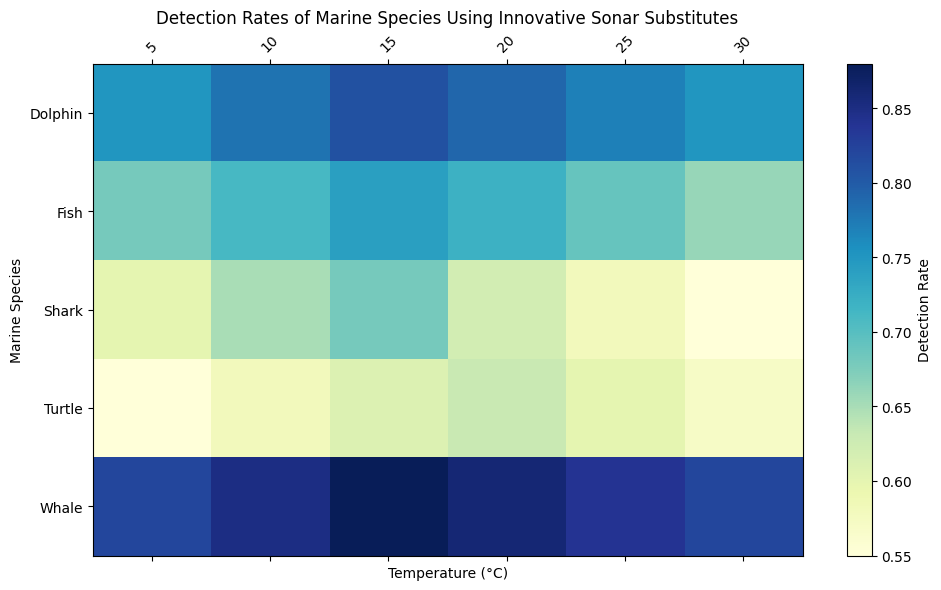What is the detection rate of dolphins at 15°C? Locate the row for Dolphins and the column for 15°C. The value at their intersection is 0.81.
Answer: 0.81 Which marine species has the highest detection rate at 10°C? Compare the detection rates at 10°C across all species. Whale has the highest value at 0.85.
Answer: Whale How does the detection rate of turtles change from 5°C to 25°C? Locate the detection rates for Turtles at 5°C (0.55) and 25°C (0.60). The rate increases as the temperature rises from 5°C to 25°C.
Answer: Increases What is the average detection rate for sharks across all temperatures? Sum the detection rates for Sharks at all temperatures (0.60 + 0.65 + 0.68 + 0.62 + 0.58 + 0.55) = 3.68. Divide by the number of temperatures (6). 3.68 / 6 = 0.613.
Answer: 0.613 Which species shows the least variation in detection rates across temperatures? Calculate the range of detection rates for each species. Dolphins range from 0.75 to 0.81, Sharks from 0.55 to 0.68, Whales from 0.82 to 0.88, Turtles from 0.55 to 0.63, Fish from 0.66 to 0.74. Whales have the least variation (range=0.06).
Answer: Whale Is there a temperature where the detection rates are equal for any two species? Compare the detection rates at each temperature. At 5°C, no detection rates are equal. Repeat for 10°C, 15°C, 20°C, 25°C, 30°C. At 30°C, Dolphins and Whales both have a detection rate of 0.75.
Answer: Yes, at 30°C Which species experiences the largest drop in detection rate as the temperature increases from 15°C to 30°C? Calculate the drop for each species from 15°C to 30°C. Dolphins drop by 0.81 - 0.75 = 0.06, Sharks by 0.68 - 0.55 = 0.13, Whales by 0.88 - 0.82 = 0.06, Turtles by 0.61 - 0.57 = 0.04, Fish by 0.74 - 0.66 = 0.08. Sharks experience the greatest drop (0.13).
Answer: Shark At which temperature is the detection rate for fish the highest? Locate the row for Fish and identify the maximum value in that row. The highest detection rate for Fish is 0.74 at 15°C.
Answer: 15°C 